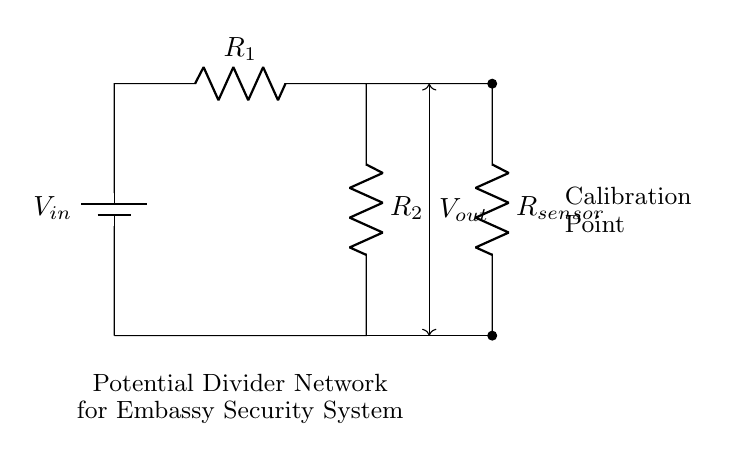What is the input voltage of the circuit? The input voltage, denoted as V_in, represents the potential difference applied across the resistor network. It is the first component in the diagram and is explicitly labeled.
Answer: V_in What are the values of the resistors in the circuit? The resistors R_1 and R_2 are shown in the diagram, indicating they are part of the potential divider network. However, their numerical values are not specified in the provided diagram.
Answer: Not specified Where is the output voltage measured in the circuit? The output voltage, V_out, is measured at the junction between the two resistors R_1 and R_2, as highlighted in the diagram. It is the point from which the calibration sensor also connects.
Answer: At the junction of R_1 and R_2 What is the purpose of the R_sensor in this circuit? R_sensor is part of the potential divider network that calibrates the voltage output. Its specific role is to modify the output voltage based on the resistance of the sensor, helping to adjust readings for the embassy security systems.
Answer: Calibration How does the output voltage change with respect to R_1 and R_2? The output voltage is determined by the voltage divider rule, where V_out is proportional to R_2 over the sum of R_1 and R_2, multiplied by the input voltage (V_in). This means varying R_1 or R_2 will affect V_out accordingly.
Answer: V_out = V_in * (R_2 / (R_1 + R_2)) What happens to V_out if R_2 is much smaller than R_1? If R_2 is much smaller than R_1, V_out approaches zero because the majority of the voltage drop occurs across R_1, making R_2's contribution negligible in the voltage division.
Answer: V_out approaches zero What is the significance of the calibration point in the circuit? The calibration point is critical as it indicates where measurements are taken for fine-tuning the sensor output. This ensures that the sensor calibrates properly with the given voltage divider, making accurate readings essential for security systems in embassies.
Answer: Sensor calibration 